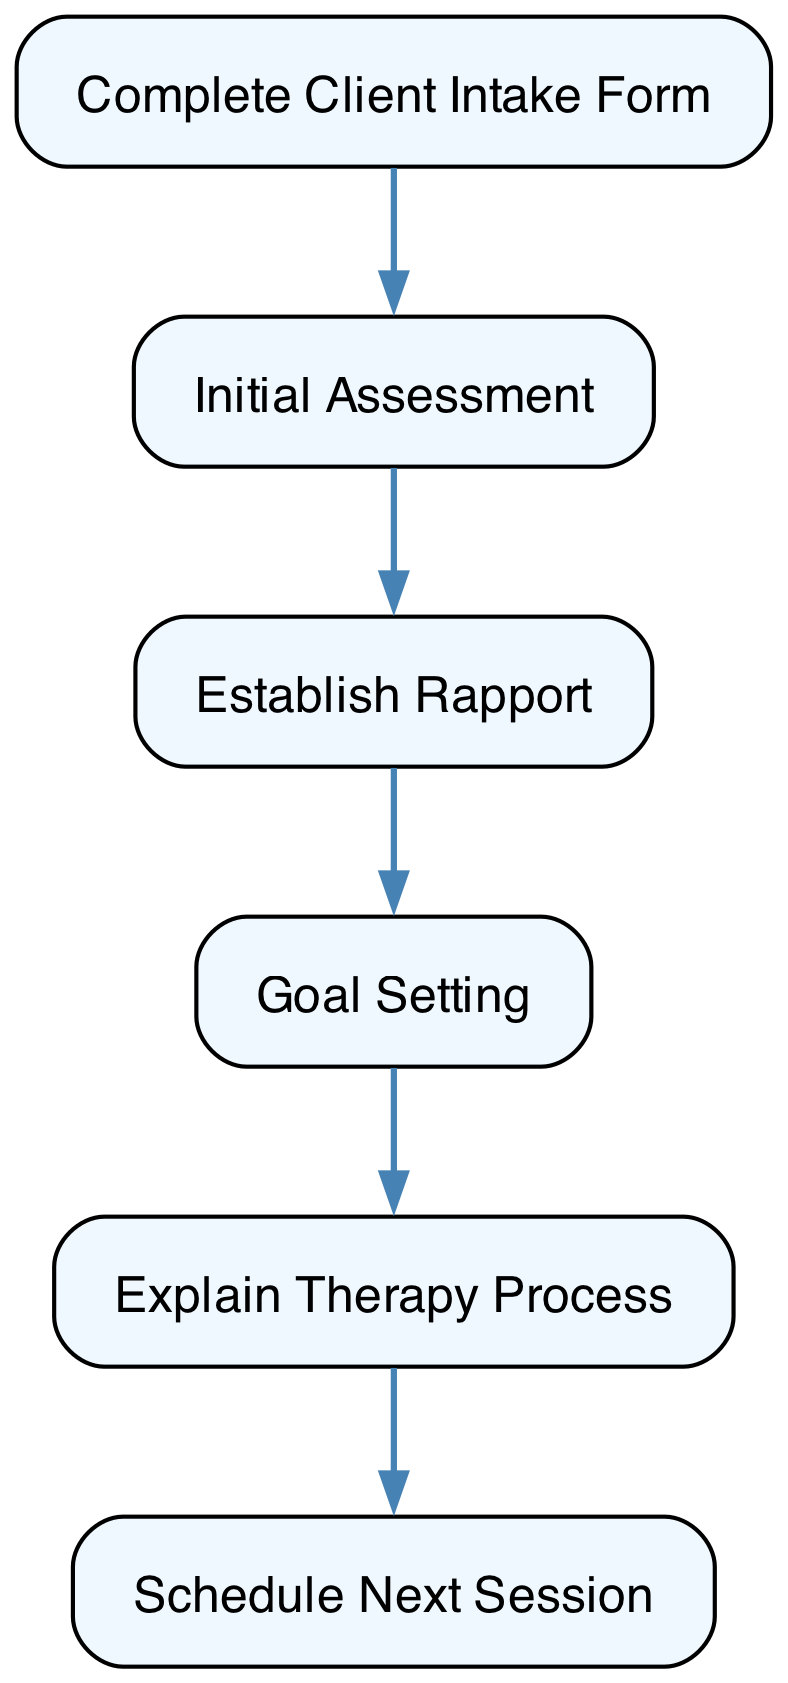What is the first step in the client intake process? The first step in the flow chart is the "Complete Client Intake Form," which indicates that the client initiates the process by filling out a form with their personal details and reasons for therapy.
Answer: Complete Client Intake Form How many steps are there in the client intake process? By counting the nodes in the diagram, there are a total of six distinct steps in the client intake process, which are sequentially arranged.
Answer: 6 What is the relationship between "Establish Rapport" and "Goal Setting"? "Establish Rapport" comes before "Goal Setting" in the flow chart, indicating that a trusting relationship is built before discussing goals.
Answer: Establish Rapport before Goal Setting What does the psychologist explain during the intake process? The psychologist explains the therapy process, covering details like confidentiality and session structure to ensure the client understands what to expect.
Answer: Explain Therapy Process What is the last step of the client intake process? The last step is "Schedule Next Session," where the psychologist and client agree on the next appointment details.
Answer: Schedule Next Session Which step emphasizes the importance of building a trusting relationship? The "Establish Rapport" step focuses specifically on building a trusting relationship through active listening and empathetic communication.
Answer: Establish Rapport What does a psychologist do after the initial assessment? Following the initial assessment, the psychologist typically moves to "Establish Rapport" to ensure a supportive environment for the client.
Answer: Establish Rapport Which process is described as a collaborative discussion? The "Goal Setting" process is described as a collaborative discussion between the psychologist and client towards setting specific goals.
Answer: Goal Setting How does the flow of the intake process start and end? The flow starts with the "Complete Client Intake Form" and ends with "Schedule Next Session," creating a clear beginning and conclusion to the intake process.
Answer: Complete Client Intake Form to Schedule Next Session 